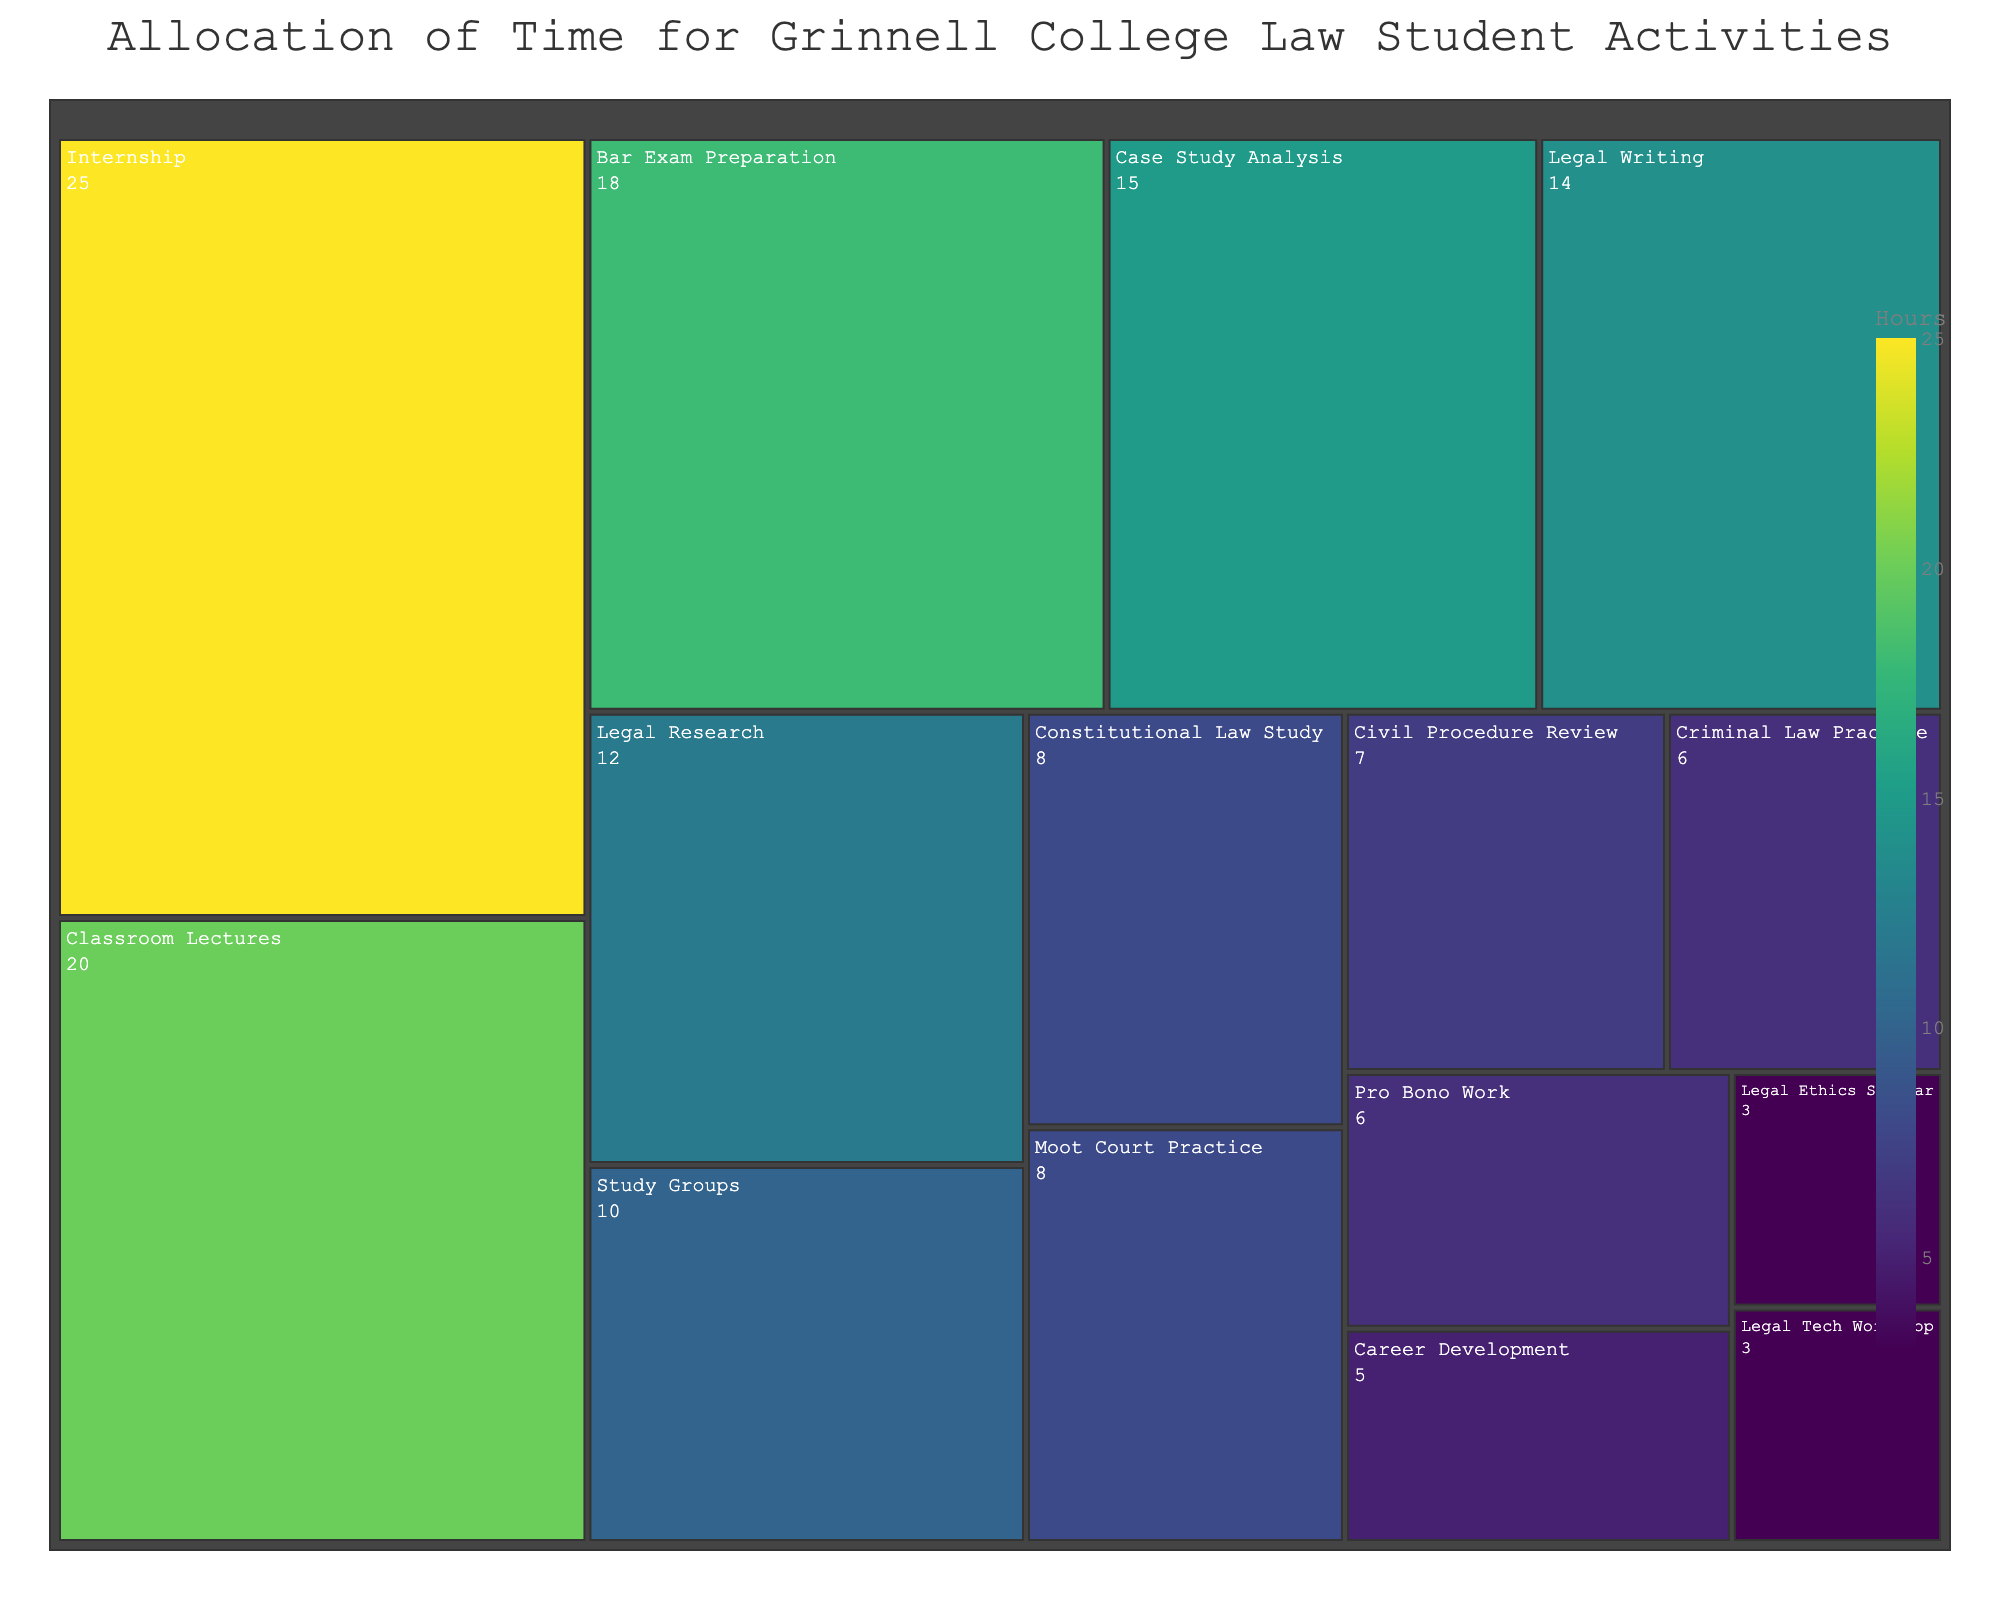How many activities are there in total? Count each distinct activity segment on the treemap to find the total number of activities listed.
Answer: 15 Which activity requires the most time? Identify the segment with the largest area, as larger areas correspond to more hours allocated.
Answer: Internship What is the combined time spent on Classroom Lectures and Legal Writing? Add the hours for Classroom Lectures (20) and Legal Writing (14).
Answer: 34 Which activities take up the least amount of time? Identify the segments with the smallest areas, which correspond to the activities with the smallest number of hours allocated.
Answer: Legal Ethics Seminar and Legal Tech Workshop How much more time is spent on Bar Exam Preparation compared to Criminal Law Practice? Subtract the hours for Criminal Law Practice (6) from the hours for Bar Exam Preparation (18).
Answer: 12 What is the total time allocated to activities that involve practical experience (e.g., Internship, Moot Court Practice, Pro Bono Work)? Add the hours for Internship (25), Moot Court Practice (8), and Pro Bono Work (6).
Answer: 39 Which activity related to written work requires more time, Case Study Analysis or Legal Writing? Compare the allocated hours for Case Study Analysis (15) and Legal Writing (14).
Answer: Case Study Analysis What is the ratio of time spent on Study Groups to time spent on Career Development? Divide the hours for Study Groups (10) by the hours for Career Development (5).
Answer: 2:1 How is the color of each segment determined in the treemap? The colors correspond to the number of hours allocated for each activity, with a continuous scale from the Viridis color map indicating the range of values.
Answer: Based on hours If you sum the hours spent on Legal Research, Constitutional Law Study, and Civil Procedure Review, what is the total? Add the hours for Legal Research (12), Constitutional Law Study (8), and Civil Procedure Review (7).
Answer: 27 